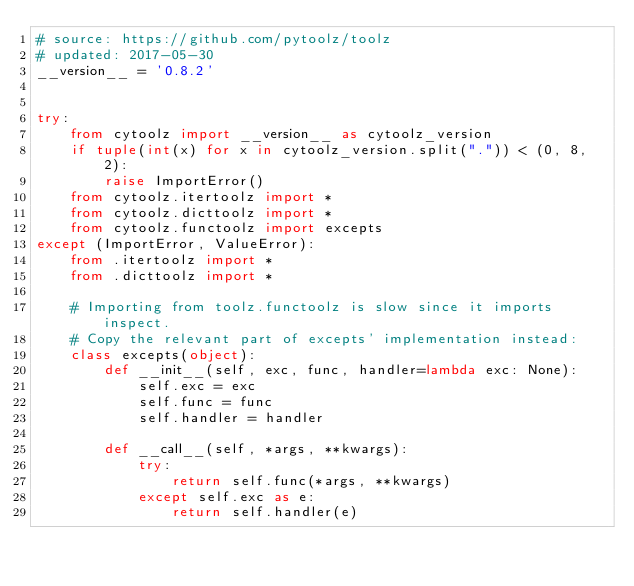Convert code to text. <code><loc_0><loc_0><loc_500><loc_500><_Python_># source: https://github.com/pytoolz/toolz
# updated: 2017-05-30
__version__ = '0.8.2'


try:
    from cytoolz import __version__ as cytoolz_version
    if tuple(int(x) for x in cytoolz_version.split(".")) < (0, 8, 2):
        raise ImportError()
    from cytoolz.itertoolz import *
    from cytoolz.dicttoolz import *
    from cytoolz.functoolz import excepts
except (ImportError, ValueError):
    from .itertoolz import *
    from .dicttoolz import *

    # Importing from toolz.functoolz is slow since it imports inspect.
    # Copy the relevant part of excepts' implementation instead:
    class excepts(object):
        def __init__(self, exc, func, handler=lambda exc: None):
            self.exc = exc
            self.func = func
            self.handler = handler

        def __call__(self, *args, **kwargs):
            try:
                return self.func(*args, **kwargs)
            except self.exc as e:
                return self.handler(e)
</code> 